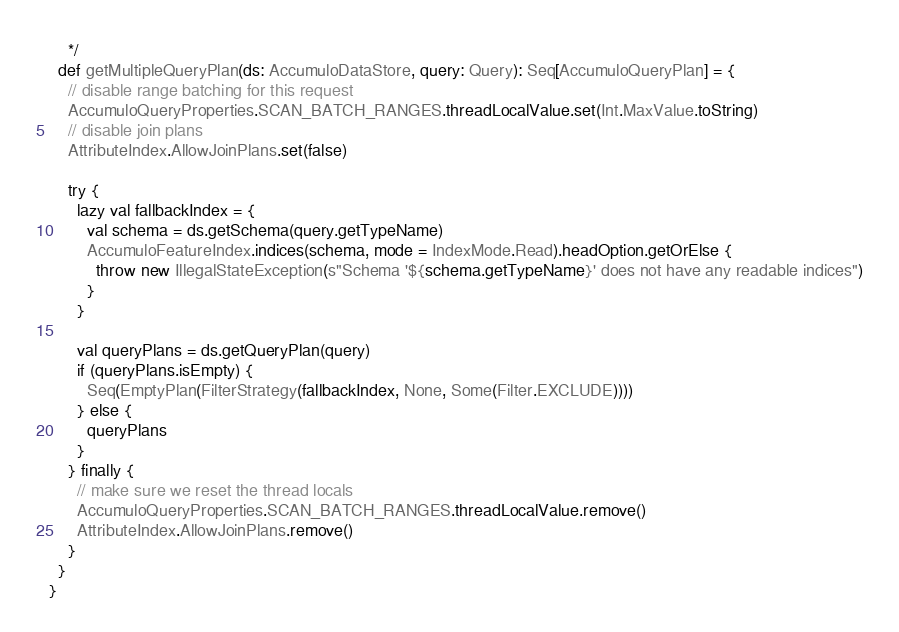<code> <loc_0><loc_0><loc_500><loc_500><_Scala_>    */
  def getMultipleQueryPlan(ds: AccumuloDataStore, query: Query): Seq[AccumuloQueryPlan] = {
    // disable range batching for this request
    AccumuloQueryProperties.SCAN_BATCH_RANGES.threadLocalValue.set(Int.MaxValue.toString)
    // disable join plans
    AttributeIndex.AllowJoinPlans.set(false)

    try {
      lazy val fallbackIndex = {
        val schema = ds.getSchema(query.getTypeName)
        AccumuloFeatureIndex.indices(schema, mode = IndexMode.Read).headOption.getOrElse {
          throw new IllegalStateException(s"Schema '${schema.getTypeName}' does not have any readable indices")
        }
      }

      val queryPlans = ds.getQueryPlan(query)
      if (queryPlans.isEmpty) {
        Seq(EmptyPlan(FilterStrategy(fallbackIndex, None, Some(Filter.EXCLUDE))))
      } else {
        queryPlans
      }
    } finally {
      // make sure we reset the thread locals
      AccumuloQueryProperties.SCAN_BATCH_RANGES.threadLocalValue.remove()
      AttributeIndex.AllowJoinPlans.remove()
    }
  }
}
</code> 